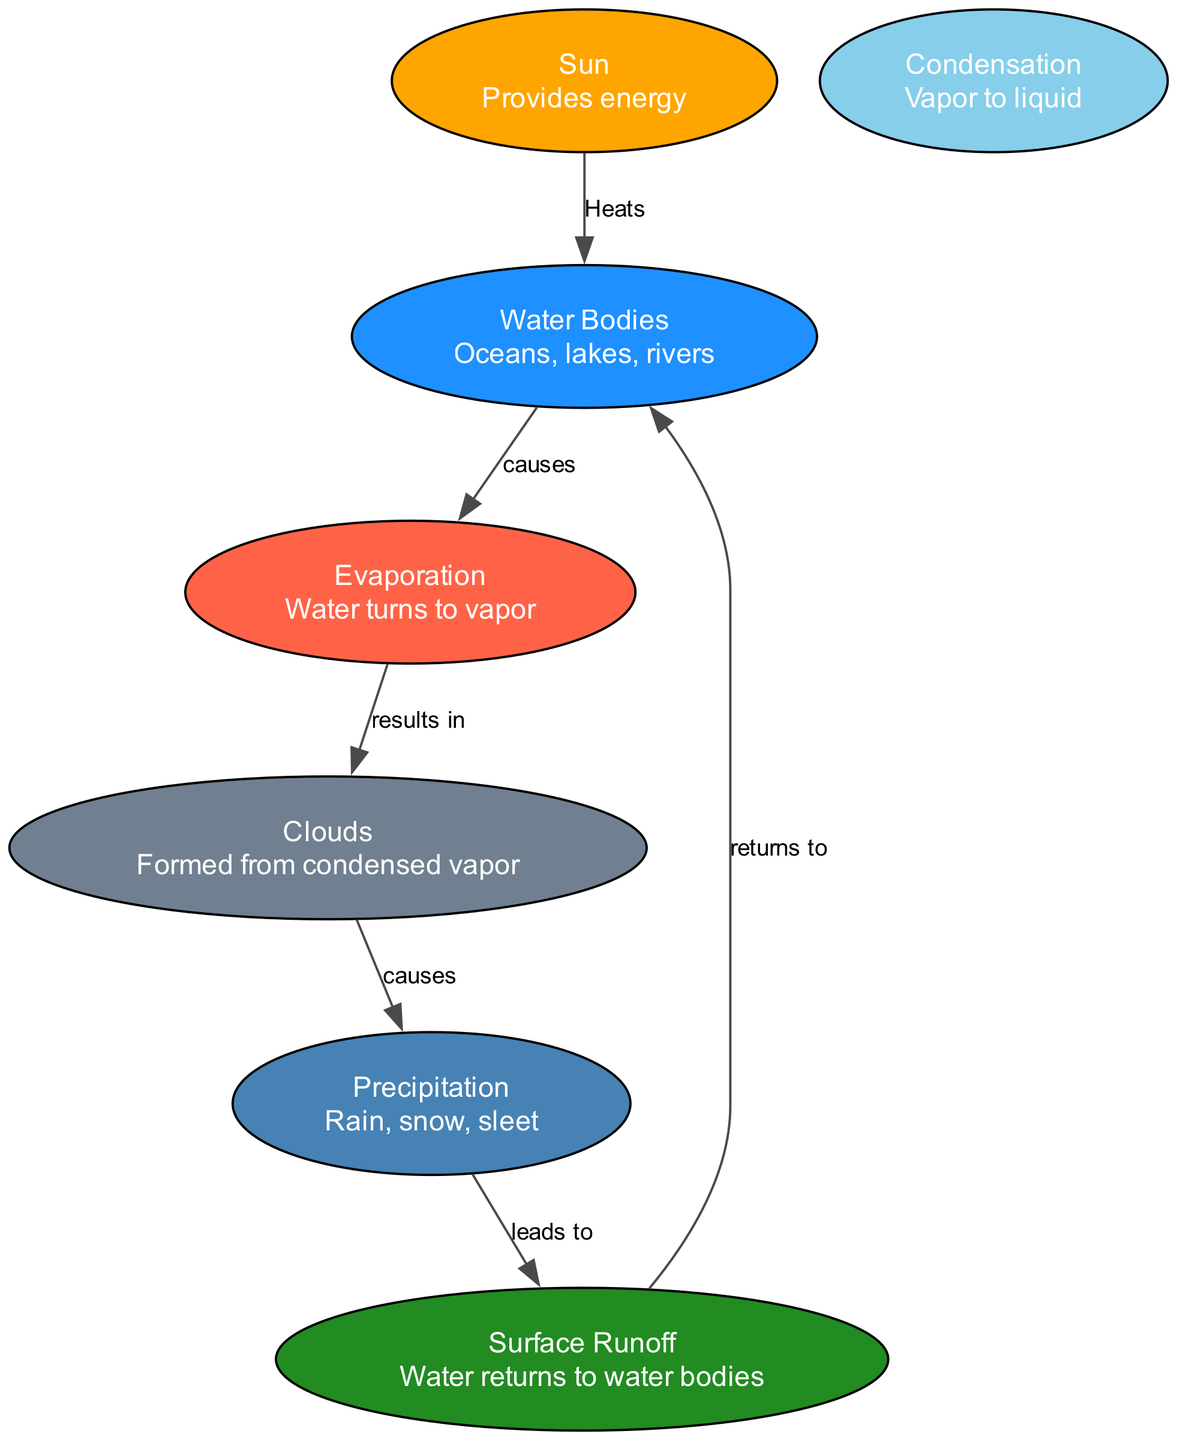What does the Sun do in the water cycle? The Sun provides energy, which is illustrated by it being connected to the Water Bodies node with the label "Heats." This indicates its role in warming the water bodies.
Answer: Provides energy How many nodes are present in the diagram? The diagram contains a total of 7 nodes, which include the Sun, Water Bodies, Evaporation, Condensation, Clouds, Precipitation, and Surface Runoff.
Answer: 7 What causes Evaporation in the water cycle? The relationship between Water Bodies and Evaporation is defined by the edge labeled "causes," indicating that the process of evaporation is due to the presence of water bodies.
Answer: Water Bodies What leads to Surface Runoff in the water cycle? The connection from Precipitation to Surface Runoff shows that precipitation, which includes rain, snow, or sleet, directly causes the surface runoff of water.
Answer: Precipitation How are Clouds formed? The diagram shows that the process of Evaporation results in the formation of Clouds, which is indicated by the edge labeled "results in" between Evaporation and Clouds.
Answer: Evaporation Which node returns water to Water Bodies? The Surface Runoff node is connected back to Water Bodies, with the label "returns to," indicating that surface runoff leads water back to the water bodies.
Answer: Surface Runoff What is the main transition between Clouds and Precipitation? The diagram indicates that Clouds cause Precipitation, which is represented by the directed edge labeled "causes." Therefore, the transition signifies that the process leading to precipitation originates from clouds.
Answer: Causes What color represents Evaporation in the diagram? The color associated with the Evaporation node is red, as per the color mapping defined in the diagram. This helps viewers quickly identify the evaporation process visually.
Answer: Red 